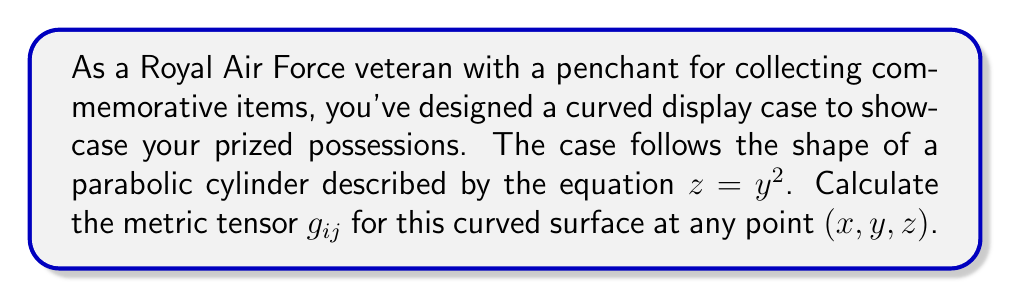Help me with this question. To find the metric tensor for the curved display case, we'll follow these steps:

1) First, we need to parameterize the surface. Let's use parameters $u$ and $v$, where:
   $x = u$
   $y = v$
   $z = v^2$

2) The metric tensor is given by:
   $$g_{ij} = \frac{\partial \vec{r}}{\partial u_i} \cdot \frac{\partial \vec{r}}{\partial u_j}$$
   where $\vec{r} = (x, y, z)$ and $(u_1, u_2) = (u, v)$

3) Let's calculate the partial derivatives:
   $$\frac{\partial \vec{r}}{\partial u} = (1, 0, 0)$$
   $$\frac{\partial \vec{r}}{\partial v} = (0, 1, 2v)$$

4) Now we can calculate each component of the metric tensor:

   $g_{11} = \frac{\partial \vec{r}}{\partial u} \cdot \frac{\partial \vec{r}}{\partial u} = 1^2 + 0^2 + 0^2 = 1$

   $g_{12} = g_{21} = \frac{\partial \vec{r}}{\partial u} \cdot \frac{\partial \vec{r}}{\partial v} = 1 \cdot 0 + 0 \cdot 1 + 0 \cdot 2v = 0$

   $g_{22} = \frac{\partial \vec{r}}{\partial v} \cdot \frac{\partial \vec{r}}{\partial v} = 0^2 + 1^2 + (2v)^2 = 1 + 4v^2$

5) Therefore, the metric tensor is:
   $$g_{ij} = \begin{pmatrix} 
   1 & 0 \\
   0 & 1 + 4v^2
   \end{pmatrix}$$

6) Remember that $v = y$ in our original coordinates, so we can express this as:
   $$g_{ij} = \begin{pmatrix} 
   1 & 0 \\
   0 & 1 + 4y^2
   \end{pmatrix}$$
Answer: $$g_{ij} = \begin{pmatrix} 
1 & 0 \\
0 & 1 + 4y^2
\end{pmatrix}$$ 